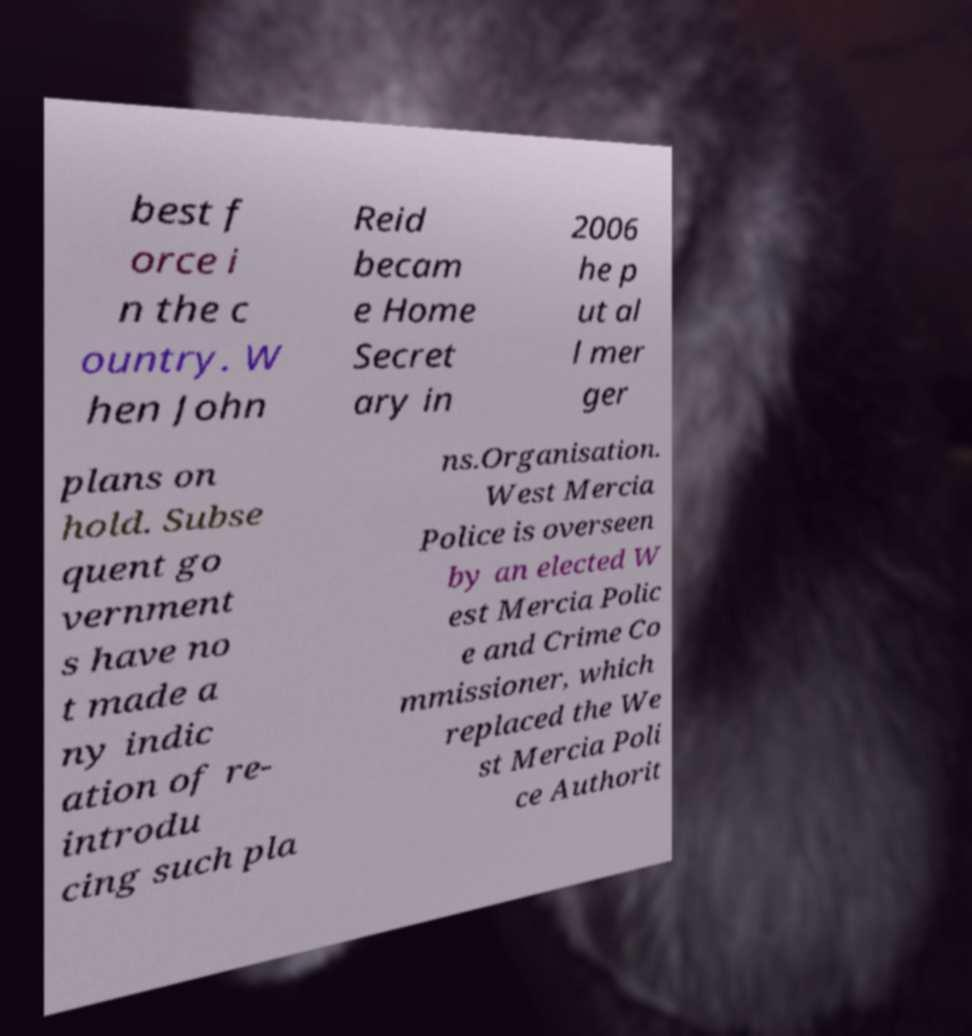Please identify and transcribe the text found in this image. best f orce i n the c ountry. W hen John Reid becam e Home Secret ary in 2006 he p ut al l mer ger plans on hold. Subse quent go vernment s have no t made a ny indic ation of re- introdu cing such pla ns.Organisation. West Mercia Police is overseen by an elected W est Mercia Polic e and Crime Co mmissioner, which replaced the We st Mercia Poli ce Authorit 